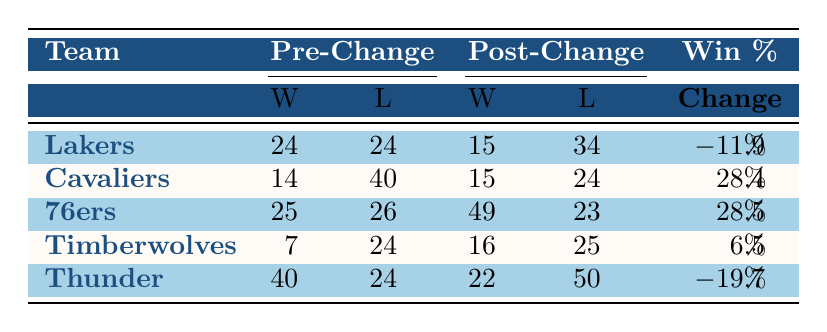What was the win-loss record of the Los Angeles Lakers before the coaching change? The Lakers' win-loss record before the coaching change is found in the "Pre-Change" section of their row, which shows 24 wins and 24 losses.
Answer: 24 wins and 24 losses Which team experienced the greatest positive change in win percentage after the coaching change? By comparing the "Win %" Change values in the table, the Cavaliers had a +28.4% change, and the 76ers had a +28.5% change. The 76ers had the greatest positive change in win percentage.
Answer: Philadelphia 76ers Did the Minnesota Timberwolves improve their win-loss record after the coaching change? The Timberwolves' pre-change record was 7 wins and 24 losses and their post-change record was 16 wins and 25 losses. The improvement in wins (from 7 to 16) indicates an improved record, though they still had more losses than wins.
Answer: Yes What is the total number of combined wins for the teams that saw a decrease in win percentage? The Lakers won 15 games and the Thunder won 22 games post-change. Adding these together gives a total of 37 combined wins.
Answer: 37 Which team had the most significant decline in win percentage, and what was that percentage? The Thunder had a win percentage change of -19.7%, which is the most significant decline when looking at the "Win %" Change column.
Answer: Oklahoma City Thunder, -19.7% How many total games did the Philadelphia 76ers win post-change compared to pre-change? The 76ers had 25 wins pre-change and 49 wins post-change. The difference between these values shows an increase of 24 wins.
Answer: 24 more wins Did the Cleveland Cavaliers have more wins post-change compared to pre-change? The Cavaliers had 14 wins pre-change and 15 wins post-change. Therefore, they experienced a slight increase in their win total.
Answer: Yes What is the average win percentage change for all teams listed in the table? Calculating the win percentage changes: -11.9% (Lakers) + 28.4% (Cavaliers) + 28.5% (76ers) + 6.5% (Timberwolves) - 19.7% (Thunder) = 31.8%. Dividing by 5 gives an average change of 6.36%.
Answer: 6.36% 